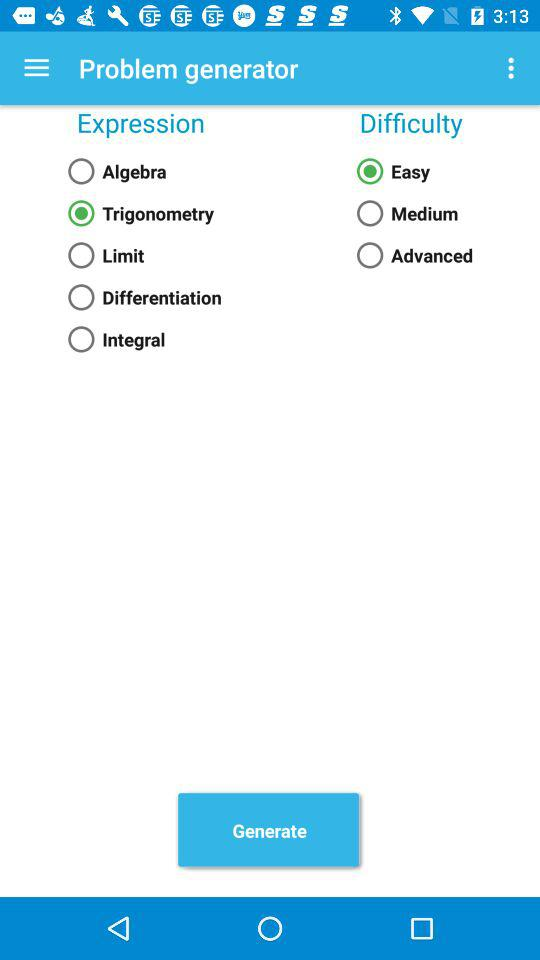What is the selected difficulty level? The selected difficulty level is "Easy". 